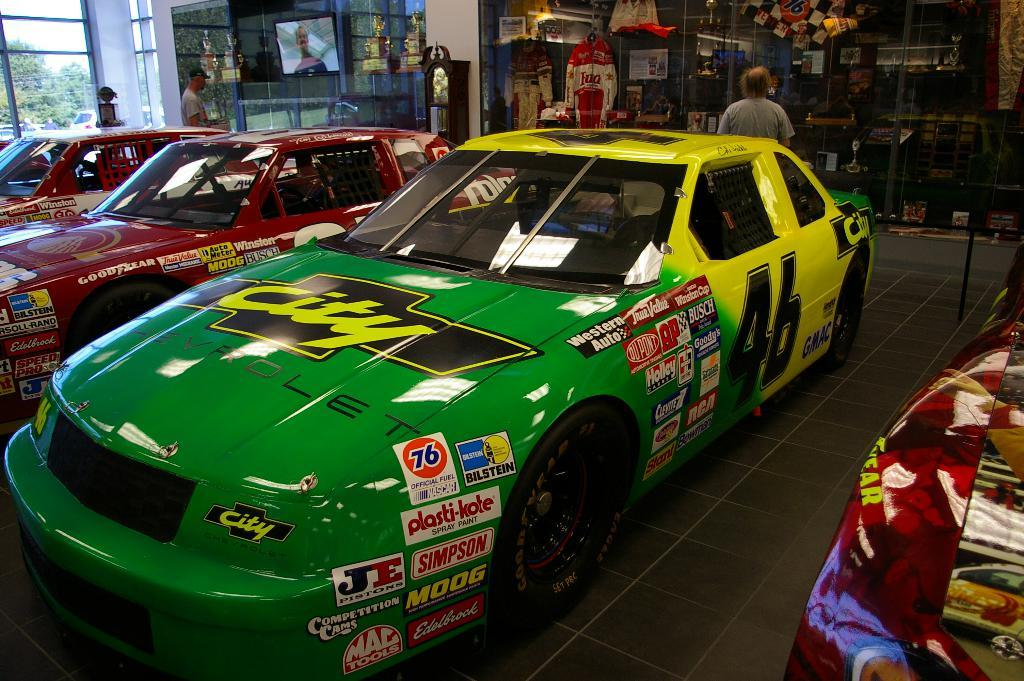<image>
Present a compact description of the photo's key features. a car that has the letters JE on it 